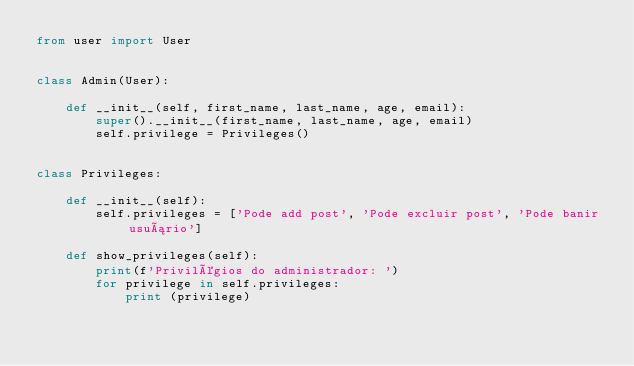Convert code to text. <code><loc_0><loc_0><loc_500><loc_500><_Python_>from user import User


class Admin(User):

    def __init__(self, first_name, last_name, age, email):
        super().__init__(first_name, last_name, age, email)
        self.privilege = Privileges()
    

class Privileges:

    def __init__(self):
        self.privileges = ['Pode add post', 'Pode excluir post', 'Pode banir usuário']

    def show_privileges(self):
        print(f'Privilégios do administrador: ')
        for privilege in self.privileges:
            print (privilege)</code> 